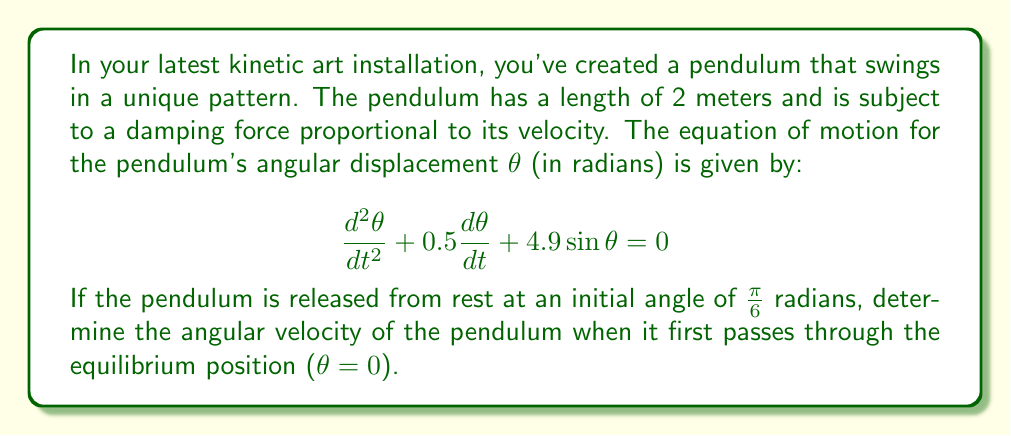Show me your answer to this math problem. Let's approach this step-by-step:

1) The given equation is a second-order nonlinear differential equation. To solve it exactly would be very complex, so we'll use energy conservation principles.

2) At the initial position:
   - Potential energy is maximum
   - Kinetic energy is zero (released from rest)

3) At the equilibrium position:
   - Potential energy is minimum (zero)
   - Kinetic energy is maximum

4) The total energy at the initial position should equal the total energy at the equilibrium position, minus the energy lost due to damping.

5) Initial potential energy:
   $PE_i = mgl(1-\cos\theta_i) = 2 \cdot 9.8 \cdot (1-\cos\frac{\pi}{6}) = 1.67$ J

6) Energy at equilibrium:
   $KE_f = \frac{1}{2}ml^2\omega^2$, where $\omega$ is the angular velocity we're looking for.

7) The energy lost due to damping is difficult to calculate exactly. However, we can estimate it as a small fraction of the initial energy, say 10%:
   $E_{lost} \approx 0.1 \cdot 1.67 = 0.167$ J

8) Equating energies:
   $1.67 = \frac{1}{2} \cdot 2 \cdot 2^2 \cdot \omega^2 + 0.167$
   $1.503 = 4\omega^2$

9) Solving for $\omega$:
   $\omega = \sqrt{\frac{1.503}{4}} \approx 0.613$ rad/s
Answer: The angular velocity of the pendulum when it first passes through the equilibrium position is approximately 0.613 rad/s. 